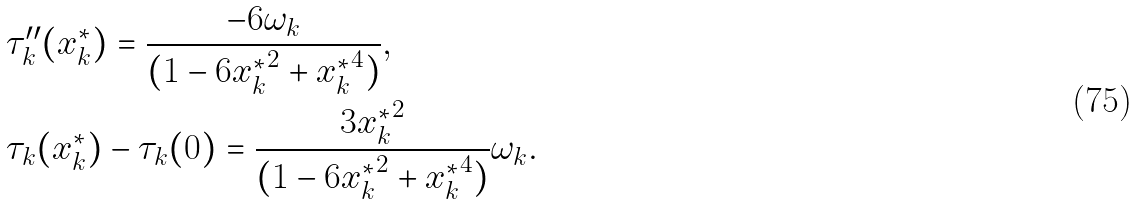Convert formula to latex. <formula><loc_0><loc_0><loc_500><loc_500>& \tau ^ { \prime \prime } _ { k } ( x _ { k } ^ { * } ) = \frac { - 6 { \omega _ { k } } } { ( 1 - 6 { x _ { k } ^ { * } } ^ { 2 } + { x _ { k } ^ { * } } ^ { 4 } ) } , \\ & \tau _ { k } ( x _ { k } ^ { * } ) - \tau _ { k } ( 0 ) = \frac { 3 { x _ { k } ^ { * } } ^ { 2 } } { ( 1 - 6 { x _ { k } ^ { * } } ^ { 2 } + { x _ { k } ^ { * } } ^ { 4 } ) } { \omega _ { k } } .</formula> 